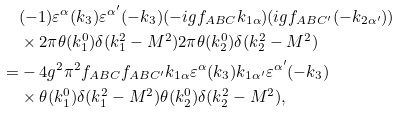Convert formula to latex. <formula><loc_0><loc_0><loc_500><loc_500>& ( - 1 ) \varepsilon ^ { \alpha } ( k _ { 3 } ) \varepsilon ^ { \alpha ^ { \prime } } ( - k _ { 3 } ) ( - i g f _ { A B C } k _ { 1 \alpha } ) ( i g f _ { A B C ^ { \prime } } ( - k _ { 2 \alpha ^ { \prime } } ) ) \\ & \times 2 \pi \theta ( k _ { 1 } ^ { 0 } ) \delta ( k _ { 1 } ^ { 2 } - M ^ { 2 } ) 2 \pi \theta ( k _ { 2 } ^ { 0 } ) \delta ( k _ { 2 } ^ { 2 } - M ^ { 2 } ) \\ = & - 4 g ^ { 2 } \pi ^ { 2 } f _ { A B C } f _ { A B C ^ { \prime } } k _ { 1 \alpha } \varepsilon ^ { \alpha } ( k _ { 3 } ) k _ { 1 \alpha ^ { \prime } } \varepsilon ^ { \alpha ^ { \prime } } ( - k _ { 3 } ) \\ & \times \theta ( k _ { 1 } ^ { 0 } ) \delta ( k _ { 1 } ^ { 2 } - M ^ { 2 } ) \theta ( k _ { 2 } ^ { 0 } ) \delta ( k _ { 2 } ^ { 2 } - M ^ { 2 } ) ,</formula> 